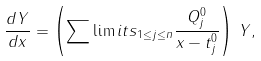Convert formula to latex. <formula><loc_0><loc_0><loc_500><loc_500>\frac { d Y } { d x } = \left ( \sum \lim i t s _ { 1 \leq j \leq n } \frac { Q _ { j } ^ { 0 } } { x - t _ { j } ^ { 0 } } \right ) \, Y ,</formula> 